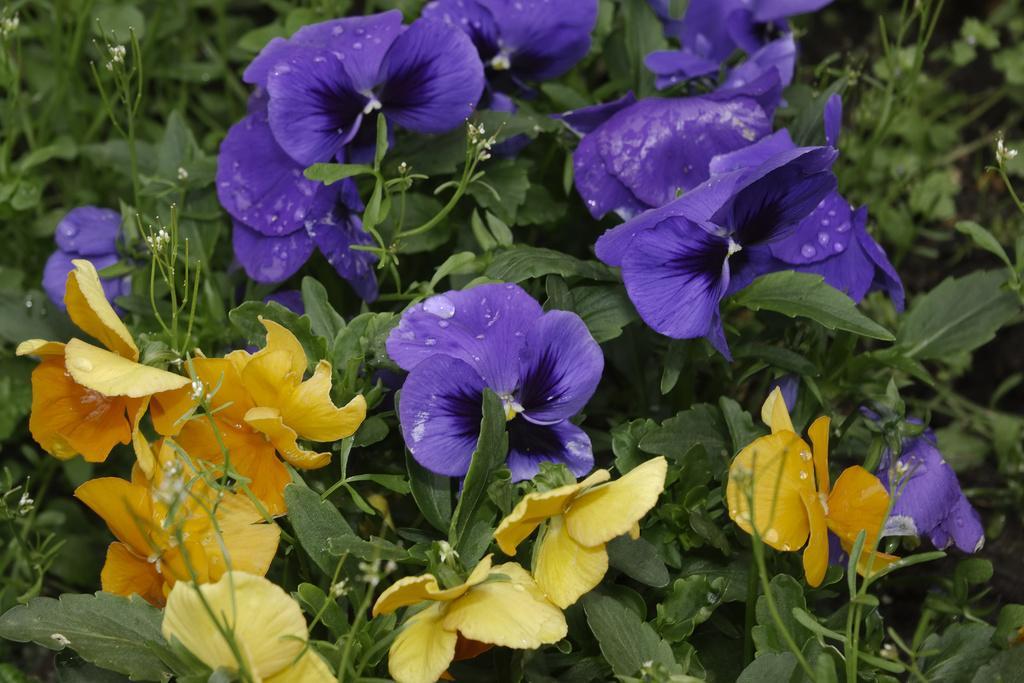How would you summarize this image in a sentence or two? In the image there are some trees with blue color flower and yellow color flower on it. 